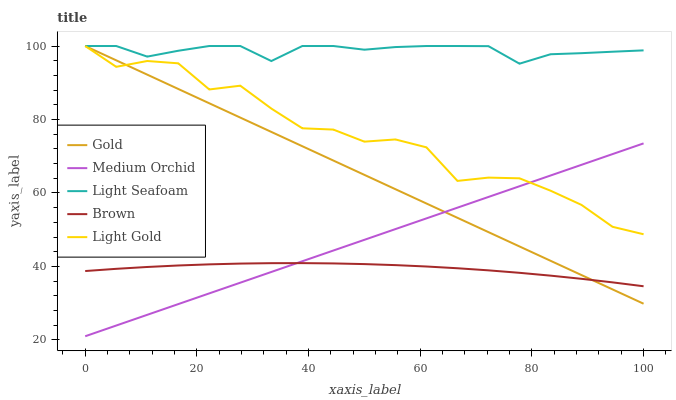Does Brown have the minimum area under the curve?
Answer yes or no. Yes. Does Light Seafoam have the maximum area under the curve?
Answer yes or no. Yes. Does Medium Orchid have the minimum area under the curve?
Answer yes or no. No. Does Medium Orchid have the maximum area under the curve?
Answer yes or no. No. Is Medium Orchid the smoothest?
Answer yes or no. Yes. Is Light Gold the roughest?
Answer yes or no. Yes. Is Brown the smoothest?
Answer yes or no. No. Is Brown the roughest?
Answer yes or no. No. Does Medium Orchid have the lowest value?
Answer yes or no. Yes. Does Brown have the lowest value?
Answer yes or no. No. Does Gold have the highest value?
Answer yes or no. Yes. Does Medium Orchid have the highest value?
Answer yes or no. No. Is Brown less than Light Gold?
Answer yes or no. Yes. Is Light Gold greater than Brown?
Answer yes or no. Yes. Does Light Seafoam intersect Light Gold?
Answer yes or no. Yes. Is Light Seafoam less than Light Gold?
Answer yes or no. No. Is Light Seafoam greater than Light Gold?
Answer yes or no. No. Does Brown intersect Light Gold?
Answer yes or no. No. 